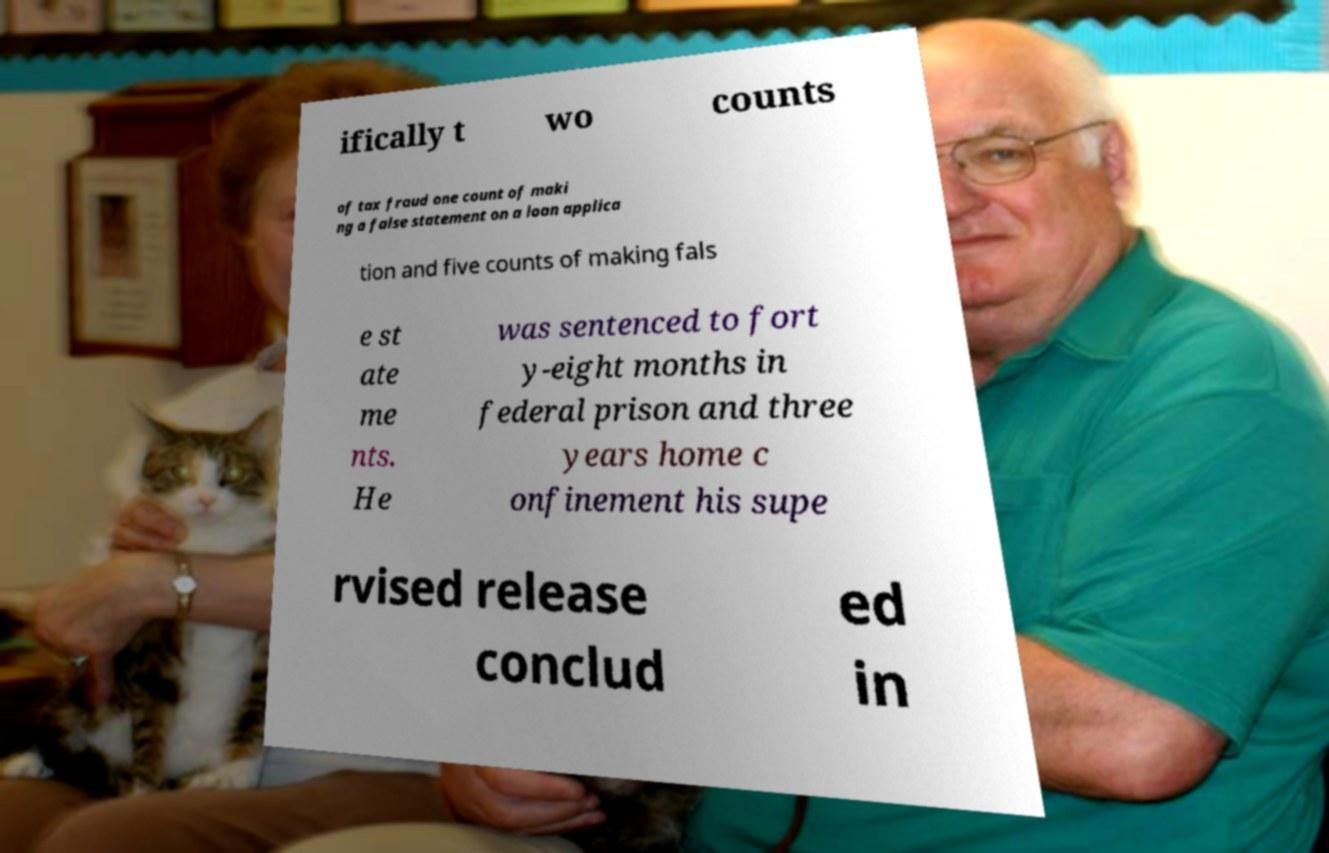Could you extract and type out the text from this image? ifically t wo counts of tax fraud one count of maki ng a false statement on a loan applica tion and five counts of making fals e st ate me nts. He was sentenced to fort y-eight months in federal prison and three years home c onfinement his supe rvised release conclud ed in 